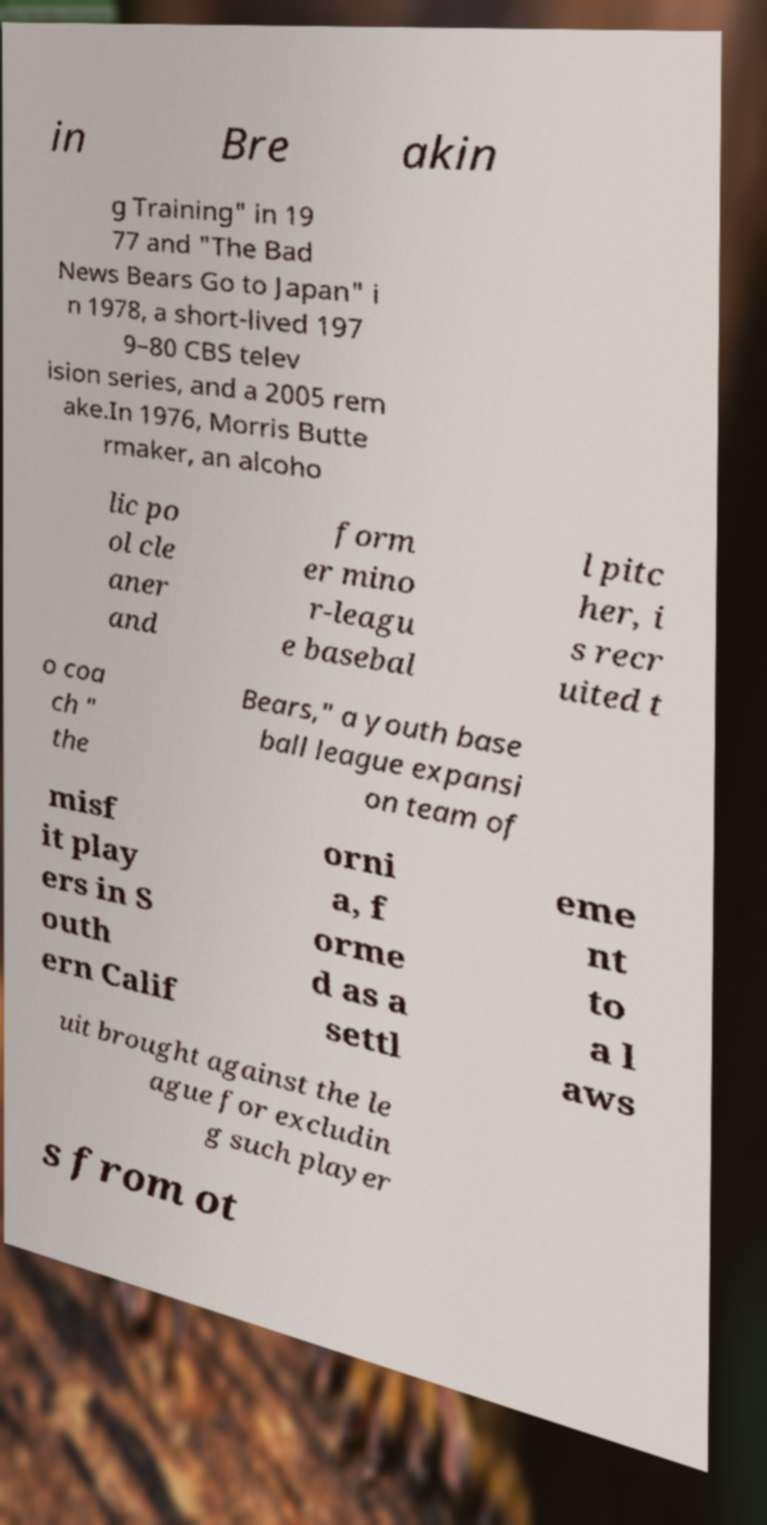There's text embedded in this image that I need extracted. Can you transcribe it verbatim? in Bre akin g Training" in 19 77 and "The Bad News Bears Go to Japan" i n 1978, a short-lived 197 9–80 CBS telev ision series, and a 2005 rem ake.In 1976, Morris Butte rmaker, an alcoho lic po ol cle aner and form er mino r-leagu e basebal l pitc her, i s recr uited t o coa ch " the Bears," a youth base ball league expansi on team of misf it play ers in S outh ern Calif orni a, f orme d as a settl eme nt to a l aws uit brought against the le ague for excludin g such player s from ot 